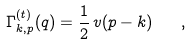Convert formula to latex. <formula><loc_0><loc_0><loc_500><loc_500>\Gamma _ { k , p } ^ { ( t ) } ( q ) = \frac { 1 } { 2 } \, v ( { p } - { k } ) \quad ,</formula> 